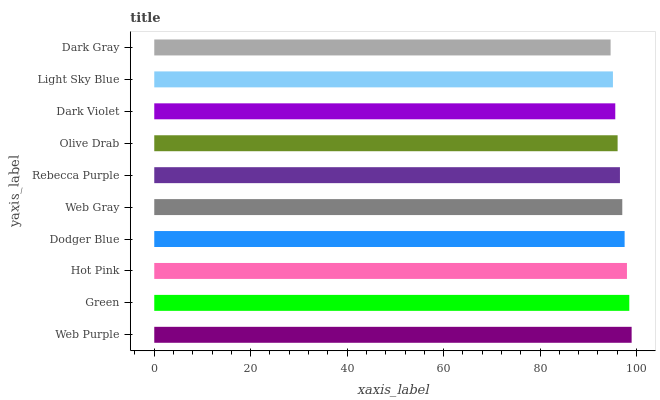Is Dark Gray the minimum?
Answer yes or no. Yes. Is Web Purple the maximum?
Answer yes or no. Yes. Is Green the minimum?
Answer yes or no. No. Is Green the maximum?
Answer yes or no. No. Is Web Purple greater than Green?
Answer yes or no. Yes. Is Green less than Web Purple?
Answer yes or no. Yes. Is Green greater than Web Purple?
Answer yes or no. No. Is Web Purple less than Green?
Answer yes or no. No. Is Web Gray the high median?
Answer yes or no. Yes. Is Rebecca Purple the low median?
Answer yes or no. Yes. Is Light Sky Blue the high median?
Answer yes or no. No. Is Olive Drab the low median?
Answer yes or no. No. 